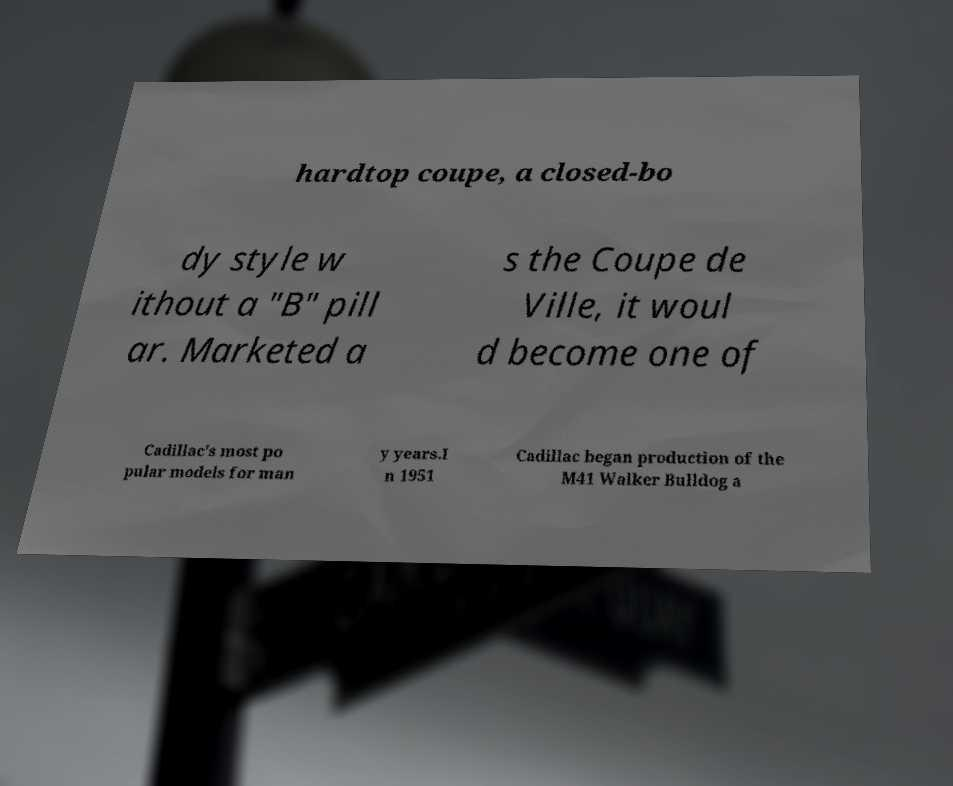For documentation purposes, I need the text within this image transcribed. Could you provide that? hardtop coupe, a closed-bo dy style w ithout a "B" pill ar. Marketed a s the Coupe de Ville, it woul d become one of Cadillac's most po pular models for man y years.I n 1951 Cadillac began production of the M41 Walker Bulldog a 